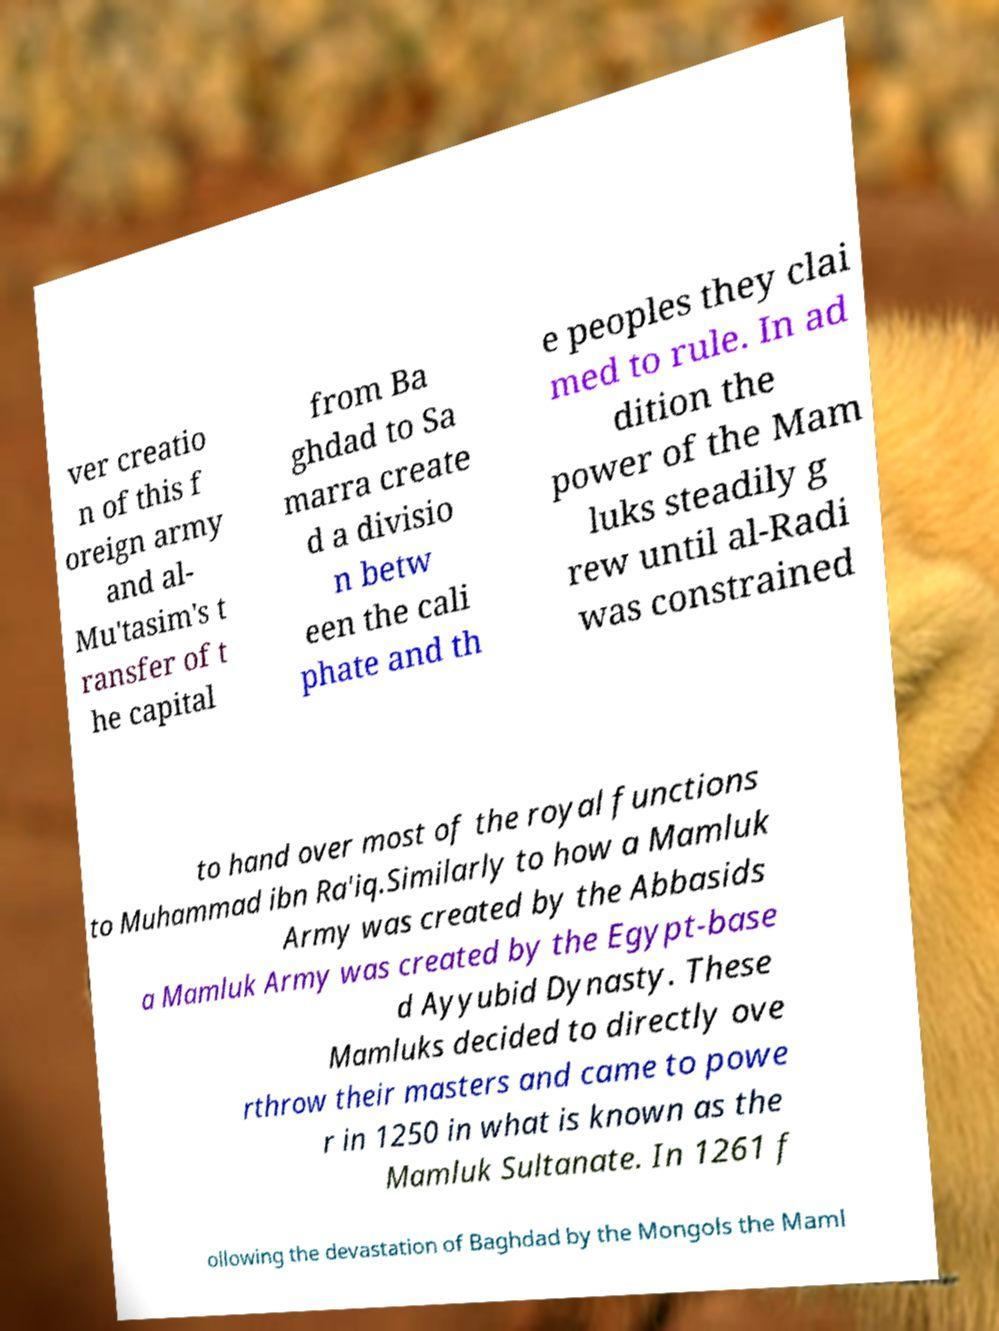There's text embedded in this image that I need extracted. Can you transcribe it verbatim? ver creatio n of this f oreign army and al- Mu'tasim's t ransfer of t he capital from Ba ghdad to Sa marra create d a divisio n betw een the cali phate and th e peoples they clai med to rule. In ad dition the power of the Mam luks steadily g rew until al-Radi was constrained to hand over most of the royal functions to Muhammad ibn Ra'iq.Similarly to how a Mamluk Army was created by the Abbasids a Mamluk Army was created by the Egypt-base d Ayyubid Dynasty. These Mamluks decided to directly ove rthrow their masters and came to powe r in 1250 in what is known as the Mamluk Sultanate. In 1261 f ollowing the devastation of Baghdad by the Mongols the Maml 